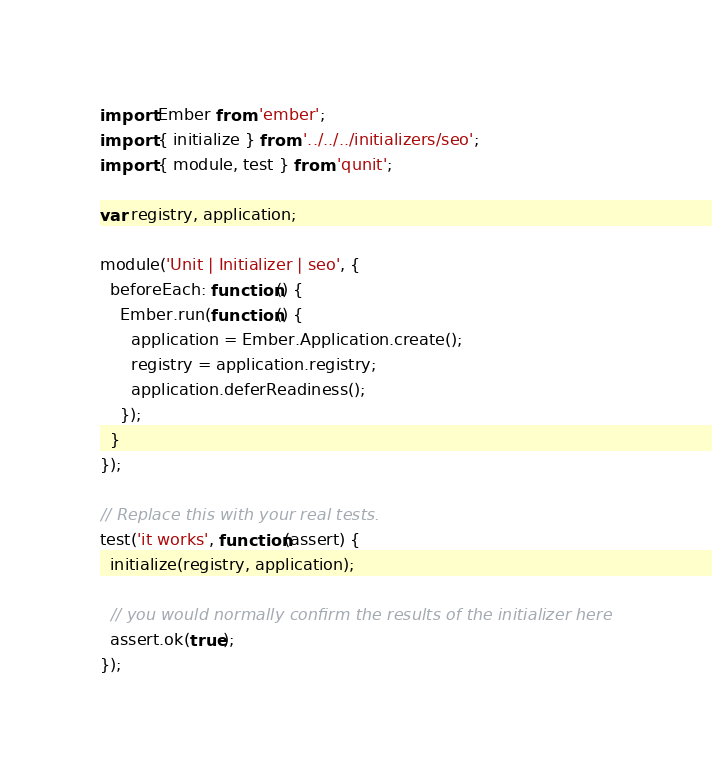Convert code to text. <code><loc_0><loc_0><loc_500><loc_500><_JavaScript_>import Ember from 'ember';
import { initialize } from '../../../initializers/seo';
import { module, test } from 'qunit';

var registry, application;

module('Unit | Initializer | seo', {
  beforeEach: function() {
    Ember.run(function() {
      application = Ember.Application.create();
      registry = application.registry;
      application.deferReadiness();
    });
  }
});

// Replace this with your real tests.
test('it works', function(assert) {
  initialize(registry, application);

  // you would normally confirm the results of the initializer here
  assert.ok(true);
});
</code> 